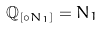Convert formula to latex. <formula><loc_0><loc_0><loc_500><loc_500>\mathbb { Q } _ { [ \circ N _ { 1 } ] } = N _ { 1 }</formula> 